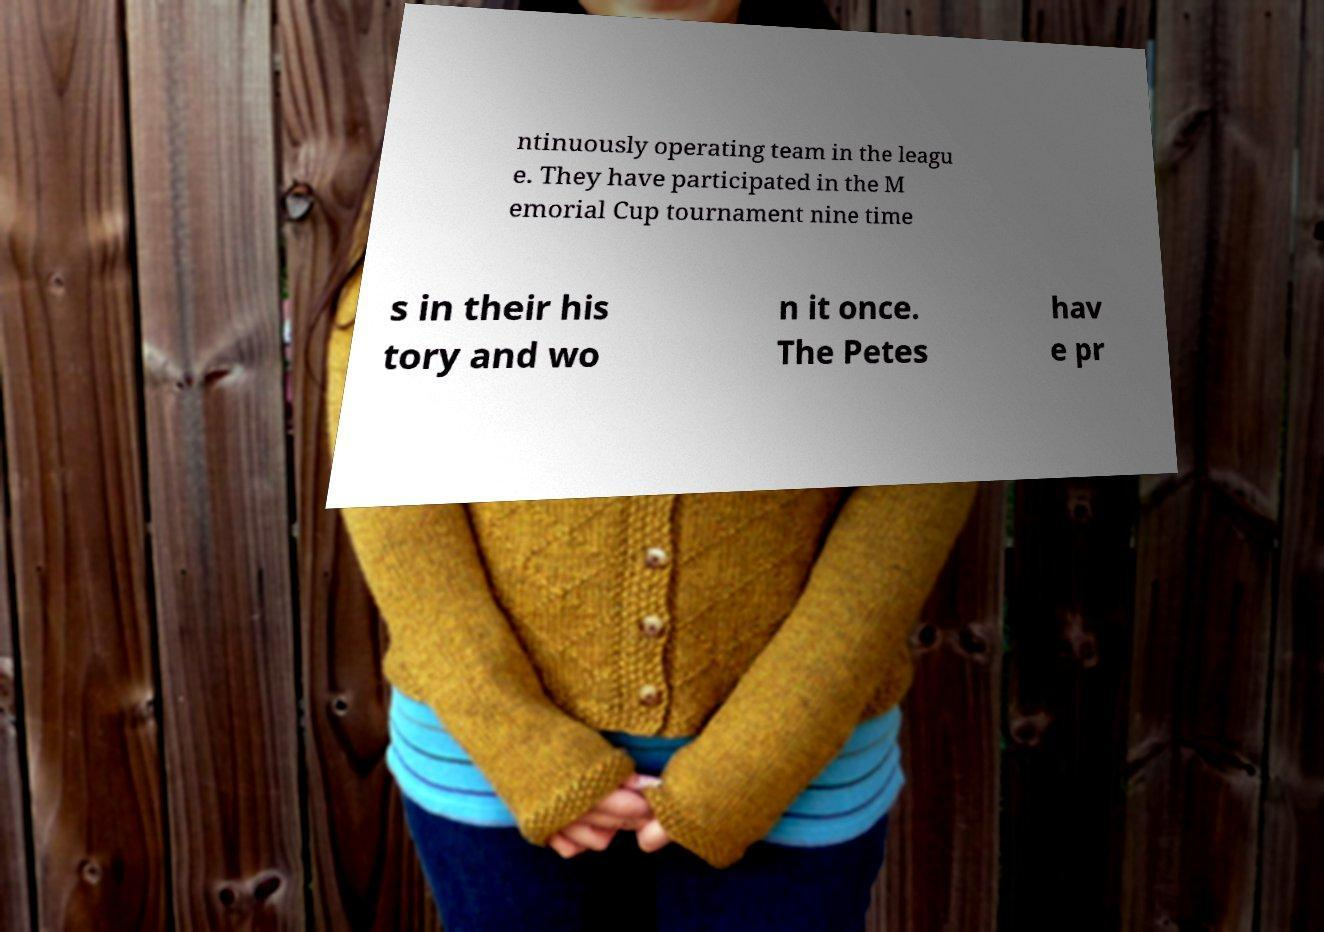Could you extract and type out the text from this image? ntinuously operating team in the leagu e. They have participated in the M emorial Cup tournament nine time s in their his tory and wo n it once. The Petes hav e pr 